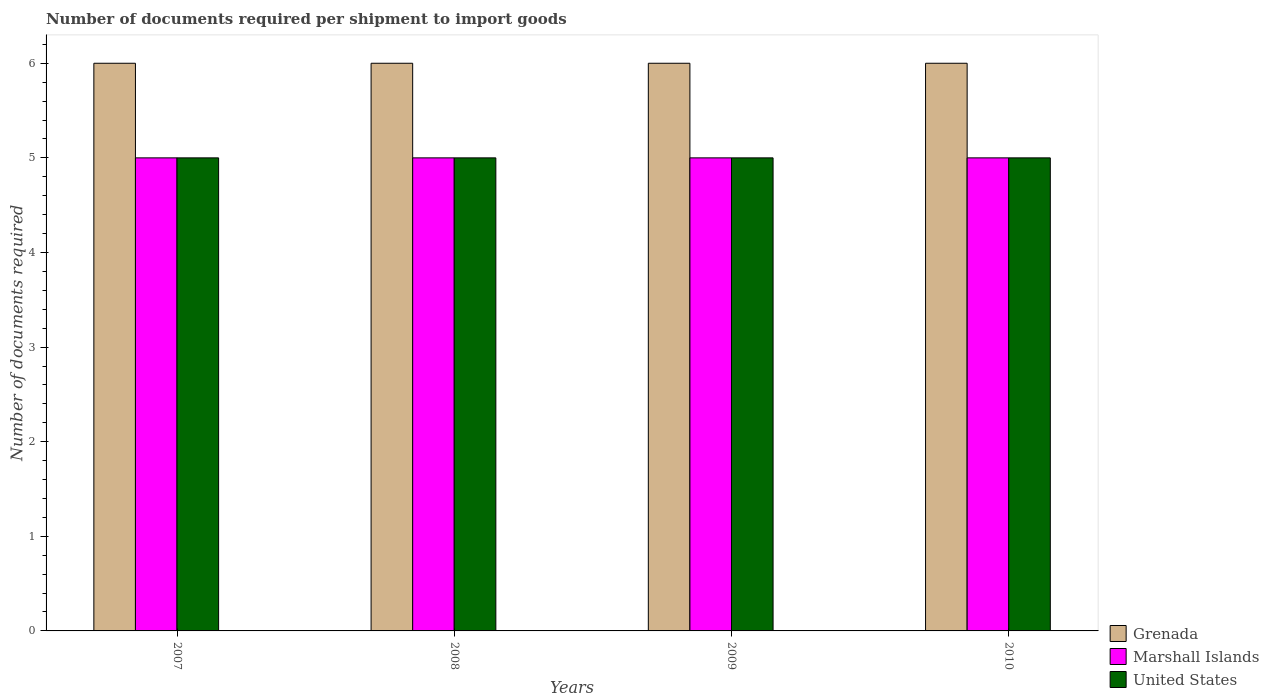How many different coloured bars are there?
Your response must be concise. 3. How many groups of bars are there?
Your answer should be very brief. 4. Are the number of bars per tick equal to the number of legend labels?
Give a very brief answer. Yes. What is the number of documents required per shipment to import goods in United States in 2007?
Your answer should be very brief. 5. Across all years, what is the maximum number of documents required per shipment to import goods in United States?
Your answer should be compact. 5. Across all years, what is the minimum number of documents required per shipment to import goods in Marshall Islands?
Offer a very short reply. 5. In which year was the number of documents required per shipment to import goods in Grenada minimum?
Give a very brief answer. 2007. What is the total number of documents required per shipment to import goods in United States in the graph?
Provide a short and direct response. 20. What is the difference between the number of documents required per shipment to import goods in Grenada in 2009 and that in 2010?
Your answer should be compact. 0. What is the difference between the number of documents required per shipment to import goods in Grenada in 2008 and the number of documents required per shipment to import goods in Marshall Islands in 2010?
Your answer should be very brief. 1. In the year 2010, what is the difference between the number of documents required per shipment to import goods in Grenada and number of documents required per shipment to import goods in United States?
Make the answer very short. 1. What is the difference between the highest and the lowest number of documents required per shipment to import goods in United States?
Your answer should be very brief. 0. In how many years, is the number of documents required per shipment to import goods in United States greater than the average number of documents required per shipment to import goods in United States taken over all years?
Your answer should be compact. 0. What does the 3rd bar from the left in 2007 represents?
Ensure brevity in your answer.  United States. What does the 3rd bar from the right in 2009 represents?
Your answer should be very brief. Grenada. Is it the case that in every year, the sum of the number of documents required per shipment to import goods in Grenada and number of documents required per shipment to import goods in United States is greater than the number of documents required per shipment to import goods in Marshall Islands?
Offer a terse response. Yes. How many bars are there?
Give a very brief answer. 12. Are all the bars in the graph horizontal?
Offer a terse response. No. How many years are there in the graph?
Your answer should be compact. 4. Does the graph contain any zero values?
Keep it short and to the point. No. Where does the legend appear in the graph?
Give a very brief answer. Bottom right. How are the legend labels stacked?
Give a very brief answer. Vertical. What is the title of the graph?
Make the answer very short. Number of documents required per shipment to import goods. What is the label or title of the X-axis?
Give a very brief answer. Years. What is the label or title of the Y-axis?
Your answer should be very brief. Number of documents required. What is the Number of documents required of United States in 2007?
Give a very brief answer. 5. What is the Number of documents required in Marshall Islands in 2008?
Keep it short and to the point. 5. What is the Number of documents required in United States in 2008?
Offer a terse response. 5. What is the Number of documents required of Marshall Islands in 2009?
Ensure brevity in your answer.  5. What is the Number of documents required of Grenada in 2010?
Your answer should be compact. 6. What is the Number of documents required of United States in 2010?
Your answer should be compact. 5. Across all years, what is the maximum Number of documents required in United States?
Your response must be concise. 5. Across all years, what is the minimum Number of documents required in Grenada?
Provide a short and direct response. 6. Across all years, what is the minimum Number of documents required in Marshall Islands?
Your response must be concise. 5. What is the total Number of documents required in Grenada in the graph?
Provide a succinct answer. 24. What is the total Number of documents required in Marshall Islands in the graph?
Keep it short and to the point. 20. What is the total Number of documents required in United States in the graph?
Provide a short and direct response. 20. What is the difference between the Number of documents required of Grenada in 2007 and that in 2008?
Provide a succinct answer. 0. What is the difference between the Number of documents required in Marshall Islands in 2007 and that in 2008?
Offer a very short reply. 0. What is the difference between the Number of documents required of United States in 2007 and that in 2008?
Give a very brief answer. 0. What is the difference between the Number of documents required in Grenada in 2007 and that in 2009?
Offer a terse response. 0. What is the difference between the Number of documents required of United States in 2007 and that in 2009?
Your answer should be very brief. 0. What is the difference between the Number of documents required in Grenada in 2007 and that in 2010?
Keep it short and to the point. 0. What is the difference between the Number of documents required of Marshall Islands in 2007 and that in 2010?
Provide a succinct answer. 0. What is the difference between the Number of documents required of Grenada in 2008 and that in 2009?
Keep it short and to the point. 0. What is the difference between the Number of documents required in Marshall Islands in 2008 and that in 2009?
Your answer should be compact. 0. What is the difference between the Number of documents required of United States in 2008 and that in 2009?
Offer a very short reply. 0. What is the difference between the Number of documents required in Grenada in 2008 and that in 2010?
Provide a succinct answer. 0. What is the difference between the Number of documents required of United States in 2008 and that in 2010?
Your response must be concise. 0. What is the difference between the Number of documents required of Marshall Islands in 2009 and that in 2010?
Your answer should be very brief. 0. What is the difference between the Number of documents required in Grenada in 2007 and the Number of documents required in Marshall Islands in 2009?
Your response must be concise. 1. What is the difference between the Number of documents required of Grenada in 2007 and the Number of documents required of Marshall Islands in 2010?
Your response must be concise. 1. What is the difference between the Number of documents required in Grenada in 2008 and the Number of documents required in United States in 2009?
Provide a succinct answer. 1. What is the difference between the Number of documents required of Grenada in 2008 and the Number of documents required of United States in 2010?
Ensure brevity in your answer.  1. What is the difference between the Number of documents required in Marshall Islands in 2008 and the Number of documents required in United States in 2010?
Provide a short and direct response. 0. What is the difference between the Number of documents required of Marshall Islands in 2009 and the Number of documents required of United States in 2010?
Provide a succinct answer. 0. In the year 2007, what is the difference between the Number of documents required in Grenada and Number of documents required in Marshall Islands?
Give a very brief answer. 1. In the year 2007, what is the difference between the Number of documents required of Grenada and Number of documents required of United States?
Offer a terse response. 1. In the year 2008, what is the difference between the Number of documents required in Grenada and Number of documents required in Marshall Islands?
Give a very brief answer. 1. In the year 2009, what is the difference between the Number of documents required in Grenada and Number of documents required in Marshall Islands?
Your response must be concise. 1. In the year 2010, what is the difference between the Number of documents required in Grenada and Number of documents required in United States?
Make the answer very short. 1. In the year 2010, what is the difference between the Number of documents required of Marshall Islands and Number of documents required of United States?
Your answer should be compact. 0. What is the ratio of the Number of documents required of Marshall Islands in 2007 to that in 2010?
Offer a terse response. 1. What is the ratio of the Number of documents required in United States in 2007 to that in 2010?
Ensure brevity in your answer.  1. What is the ratio of the Number of documents required of United States in 2008 to that in 2009?
Your answer should be very brief. 1. What is the ratio of the Number of documents required of Marshall Islands in 2008 to that in 2010?
Provide a short and direct response. 1. What is the ratio of the Number of documents required of Grenada in 2009 to that in 2010?
Keep it short and to the point. 1. What is the ratio of the Number of documents required of United States in 2009 to that in 2010?
Make the answer very short. 1. What is the difference between the highest and the second highest Number of documents required in Marshall Islands?
Offer a terse response. 0. What is the difference between the highest and the second highest Number of documents required in United States?
Offer a terse response. 0. What is the difference between the highest and the lowest Number of documents required in Marshall Islands?
Your answer should be very brief. 0. What is the difference between the highest and the lowest Number of documents required of United States?
Keep it short and to the point. 0. 